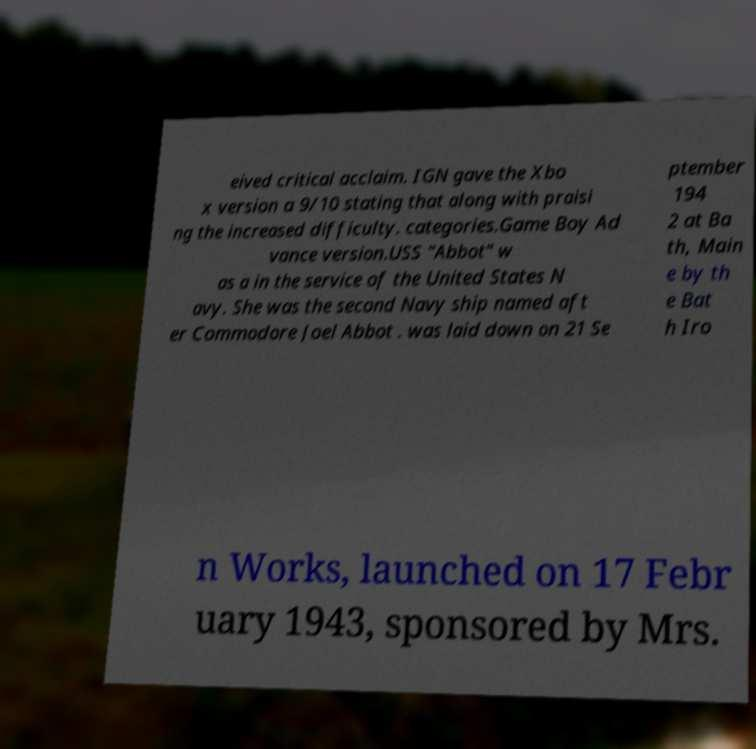For documentation purposes, I need the text within this image transcribed. Could you provide that? eived critical acclaim. IGN gave the Xbo x version a 9/10 stating that along with praisi ng the increased difficulty. categories.Game Boy Ad vance version.USS "Abbot" w as a in the service of the United States N avy. She was the second Navy ship named aft er Commodore Joel Abbot . was laid down on 21 Se ptember 194 2 at Ba th, Main e by th e Bat h Iro n Works, launched on 17 Febr uary 1943, sponsored by Mrs. 